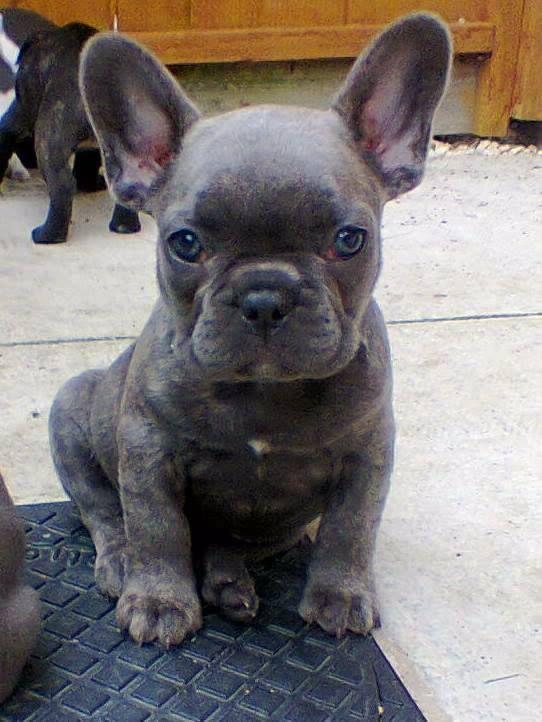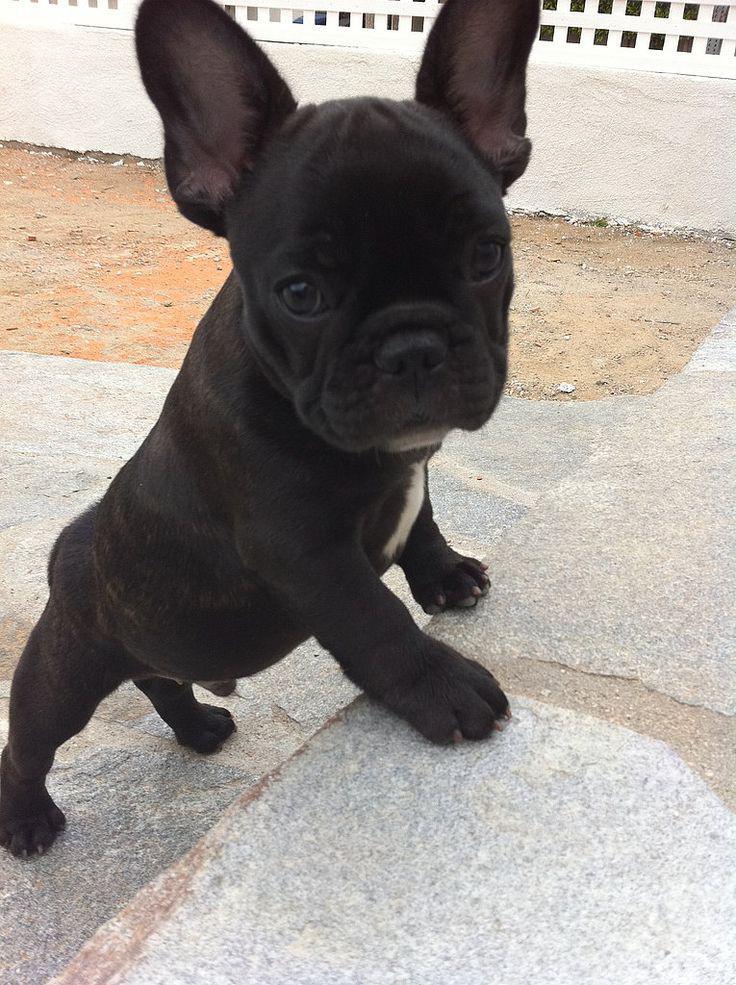The first image is the image on the left, the second image is the image on the right. For the images displayed, is the sentence "The lefthand image contains exactly one dog, which is standing on all fours, and the right image shows one sitting dog." factually correct? Answer yes or no. No. The first image is the image on the left, the second image is the image on the right. Given the left and right images, does the statement "The dog in the right image is wearing a human-like accessory." hold true? Answer yes or no. No. 